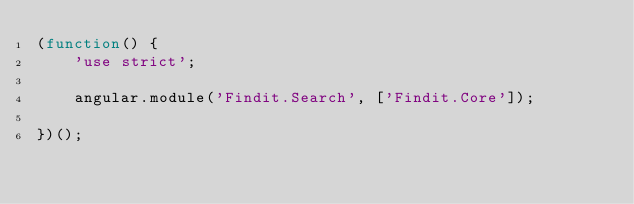<code> <loc_0><loc_0><loc_500><loc_500><_JavaScript_>(function() {
    'use strict';

    angular.module('Findit.Search', ['Findit.Core']);
    
})();</code> 